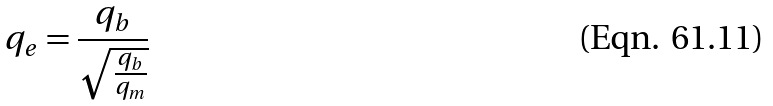Convert formula to latex. <formula><loc_0><loc_0><loc_500><loc_500>q _ { e } = \frac { q _ { b } } { \sqrt { \frac { q _ { b } } { q _ { m } } } }</formula> 